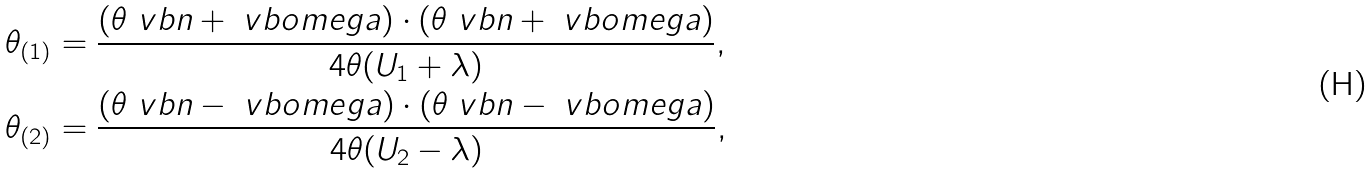Convert formula to latex. <formula><loc_0><loc_0><loc_500><loc_500>\theta _ { ( 1 ) } & = \frac { ( \theta \ v b n + \ v b o m e g a ) \cdot ( \theta \ v b n + \ v b o m e g a ) } { 4 \theta ( U _ { 1 } + \lambda ) } , \\ \theta _ { ( 2 ) } & = \frac { ( \theta \ v b n - \ v b o m e g a ) \cdot ( \theta \ v b n - \ v b o m e g a ) } { 4 \theta ( U _ { 2 } - \lambda ) } ,</formula> 